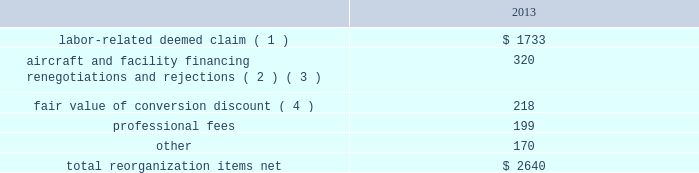Table of contents the following discussion of nonoperating income and expense excludes the results of us airways in order to provide a more meaningful year-over-year comparison .
Interest expense , net of capitalized interest decreased $ 129 million in 2014 from 2013 primarily due to a $ 63 million decrease in special charges recognized year-over-year as further described below , as well as refinancing activities that resulted in $ 65 million less interest expense recognized in 2014 .
( 1 ) in 2014 , american recognized $ 29 million of special charges relating to non-cash interest accretion on bankruptcy settlement obligations .
In 2013 , american recognized $ 48 million of special charges relating to post-petition interest expense on unsecured obligations pursuant to the plan and penalty interest related to american 2019s 10.5% ( 10.5 % ) secured notes and 7.50% ( 7.50 % ) senior secured notes .
In addition , in 2013 american recorded special charges of $ 44 million for debt extinguishment costs incurred as a result of the repayment of certain aircraft secured indebtedness , including cash interest charges and non-cash write offs of unamortized debt issuance costs .
( 2 ) as a result of the 2013 refinancing activities and the early extinguishment of american 2019s 7.50% ( 7.50 % ) senior secured notes in 2014 , american incurred $ 65 million less interest expense in 2014 as compared to 2013 .
Other nonoperating expense , net in 2014 consisted of $ 92 million of net foreign currency losses , including a $ 43 million special charge for venezuelan foreign currency losses , and $ 48 million of early debt extinguishment costs related to the prepayment of american 2019s 7.50% ( 7.50 % ) senior secured notes and other indebtedness .
The foreign currency losses were driven primarily by the strengthening of the u.s .
Dollar relative to other currencies during 2014 , principally in the latin american market , including a 48% ( 48 % ) decrease in the value of the venezuelan bolivar and a 14% ( 14 % ) decrease in the value of the brazilian real .
Other nonoperating expense , net in 2013 consisted principally of net foreign currency losses of $ 55 million and early debt extinguishment charges of $ 29 million .
Reorganization items , net reorganization items refer to revenues , expenses ( including professional fees ) , realized gains and losses and provisions for losses that are realized or incurred as a direct result of the chapter 11 cases .
The table summarizes the components included in reorganization items , net on american 2019s consolidated statement of operations for the year ended december 31 , 2013 ( in millions ) : .
( 1 ) in exchange for employees 2019 contributions to the successful reorganization , including agreeing to reductions in pay and benefits , american agreed in the plan to provide each employee group a deemed claim , which was used to provide a distribution of a portion of the equity of the reorganized entity to those employees .
Each employee group received a deemed claim amount based upon a portion of the value of cost savings provided by that group through reductions to pay and benefits as well as through certain work rule changes .
The total value of this deemed claim was approximately $ 1.7 billion .
( 2 ) amounts include allowed claims ( claims approved by the bankruptcy court ) and estimated allowed claims relating to ( i ) the rejection or modification of financings related to aircraft and ( ii ) entry of orders treated as unsecured claims with respect to facility agreements supporting certain issuances of special facility revenue .
What was the ratio of the labor-related deemed claim to professional services in 2013? 
Rationale: for every dollar spent on professional services there was 8.77 spent on labor-related deemed claim
Computations: (1733 / 199)
Answer: 8.70854. 